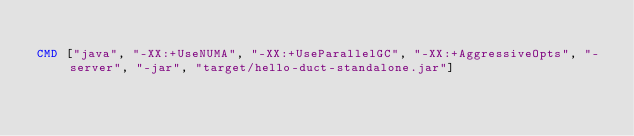Convert code to text. <code><loc_0><loc_0><loc_500><loc_500><_Dockerfile_>
CMD ["java", "-XX:+UseNUMA", "-XX:+UseParallelGC", "-XX:+AggressiveOpts", "-server", "-jar", "target/hello-duct-standalone.jar"]
</code> 